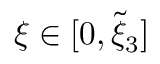<formula> <loc_0><loc_0><loc_500><loc_500>\xi \in [ 0 , \tilde { \xi } _ { 3 } ]</formula> 